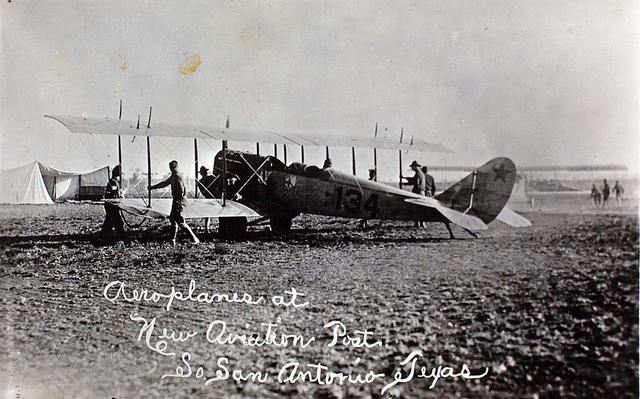Is the photo colored?
Answer briefly. No. Was this picture taken recently?
Short answer required. No. Where was it taken?
Concise answer only. San antonio, texas. 